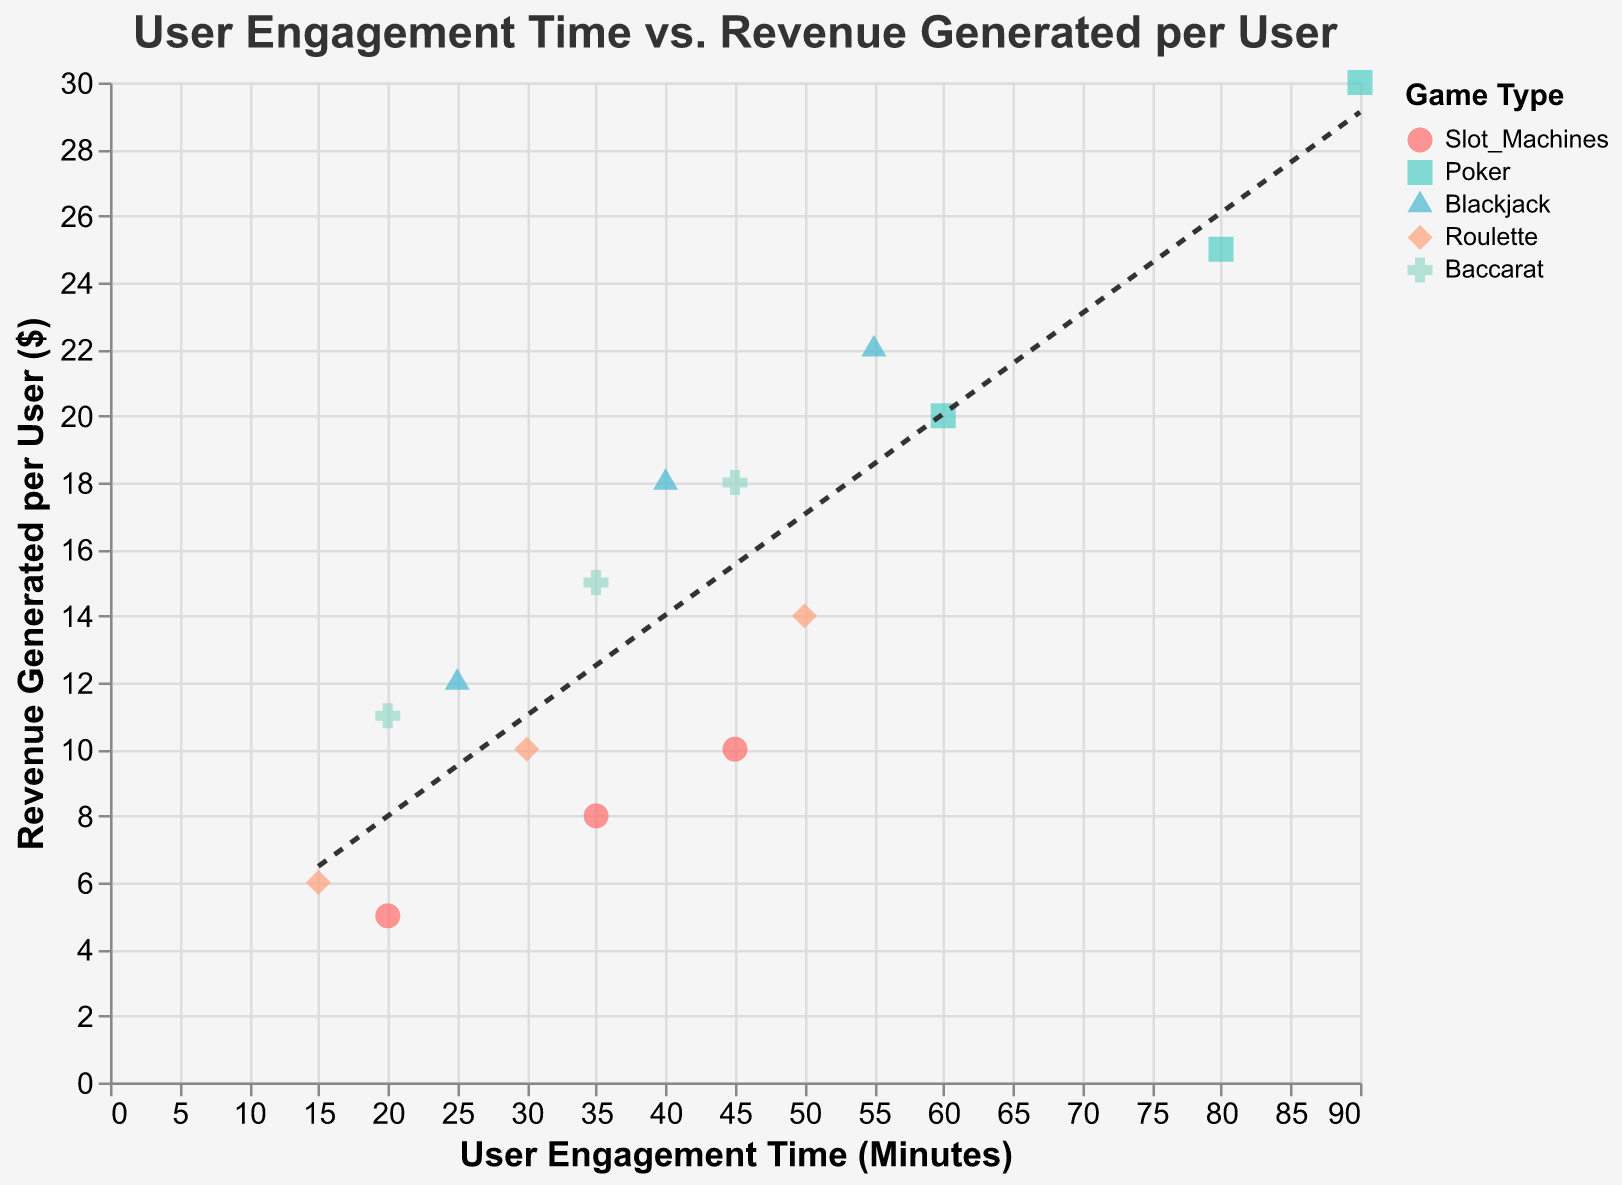Which game type has the highest user engagement time? By observing the different data points, we can see that the maximum user engagement time is 90 minutes and it corresponds to the game type "Poker".
Answer: Poker Which game type shows the highest revenue generated per user? The highest revenue generated per user is $30, and it is observed for the game type "Poker".
Answer: Poker What is the trend observed between user engagement time and revenue generated per user? The trend line shows a positive relationship between user engagement time and revenue generated per user, indicating that as user engagement time increases, the revenue generated per user also tends to increase.
Answer: Positive How many different game types are represented in the plot? By viewing the legend, we can see that there are five different game types represented: Slot Machines, Poker, Blackjack, Roulette, and Baccarat.
Answer: 5 Which game type appears to have the lowest average revenue generated per user? By comparing the individual points of each game type, "Slot Machines" appear to generate the lowest average revenue per user given the distribution of revenue values between $5 and $10.
Answer: Slot Machines What is the user engagement time for roulette at $10 revenue? There are a few data points to compare for this game type, and for roulette, the user engagement time at $10 revenue is 30 minutes.
Answer: 30 minutes Which game type has data points most widely spread out in terms of user engagement time? Poker has data points ranging from 60 to 90 minutes, showing the widest spread in terms of user engagement time.
Answer: Poker Which game type has a data point with the lowest user engagement time and what is its revenue? The lowest user engagement time is 15 minutes for Roulette, and the revenue generated at this engagement time is $6.
Answer: Roulette, $6 What is the average user engagement time for Blackjack? The user engagement times for Blackjack are 25, 40, and 55 minutes. The average engagement time is (25 + 40 + 55) / 3 = 40 minutes.
Answer: 40 minutes Which game type displays the most consistent relationship between user engagement time and revenue generated? Poker shows a consistent and linear relationship where revenue increases steadily with engagement time, as seen by the closely clustered data points and their alignment with the trend line.
Answer: Poker 